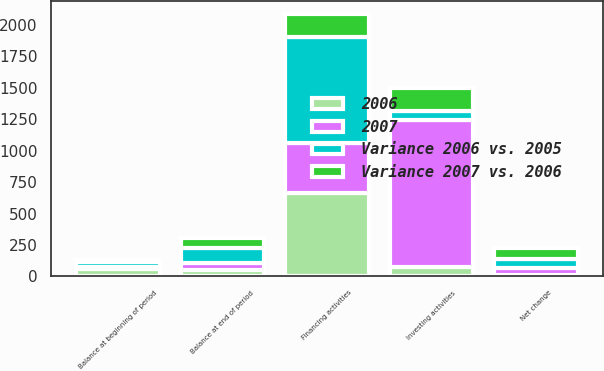Convert chart. <chart><loc_0><loc_0><loc_500><loc_500><stacked_bar_chart><ecel><fcel>Investing activities<fcel>Financing activities<fcel>Net change<fcel>Balance at beginning of period<fcel>Balance at end of period<nl><fcel>Variance 2006 vs. 2005<fcel>74<fcel>844<fcel>74<fcel>47<fcel>121<nl><fcel>2006<fcel>74<fcel>662<fcel>14<fcel>61<fcel>47<nl><fcel>Variance 2007 vs. 2006<fcel>182<fcel>182<fcel>88<fcel>14<fcel>74<nl><fcel>2007<fcel>1167<fcel>400<fcel>51<fcel>10<fcel>61<nl></chart> 